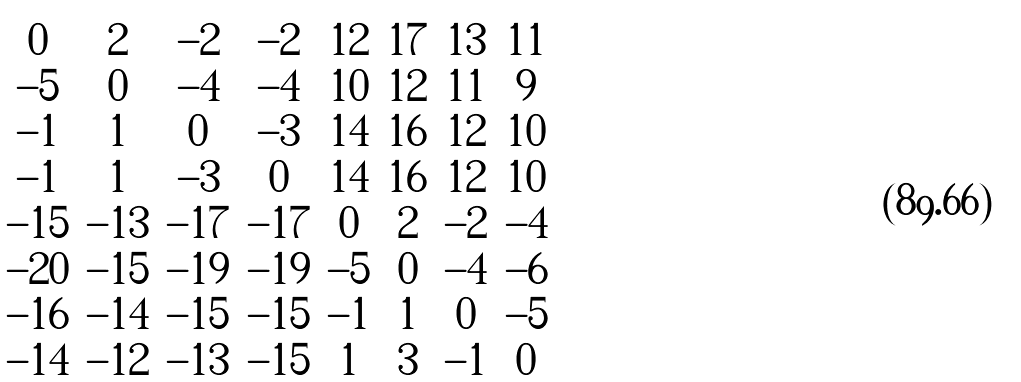Convert formula to latex. <formula><loc_0><loc_0><loc_500><loc_500>\begin{pmatrix} 0 & 2 & - 2 & - 2 & 1 2 & 1 7 & 1 3 & 1 1 \\ - 5 & 0 & - 4 & - 4 & 1 0 & 1 2 & 1 1 & 9 \\ - 1 & 1 & 0 & - 3 & 1 4 & 1 6 & 1 2 & 1 0 \\ - 1 & 1 & - 3 & 0 & 1 4 & 1 6 & 1 2 & 1 0 \\ - 1 5 & - 1 3 & - 1 7 & - 1 7 & 0 & 2 & - 2 & - 4 \\ - 2 0 & - 1 5 & - 1 9 & - 1 9 & - 5 & 0 & - 4 & - 6 \\ - 1 6 & - 1 4 & - 1 5 & - 1 5 & - 1 & 1 & 0 & - 5 \\ - 1 4 & - 1 2 & - 1 3 & - 1 5 & 1 & 3 & - 1 & 0 \end{pmatrix}</formula> 